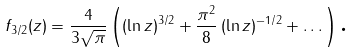<formula> <loc_0><loc_0><loc_500><loc_500>f _ { 3 / 2 } ( z ) = \frac { 4 } { 3 \sqrt { \pi } } \left ( \left ( \ln z \right ) ^ { 3 / 2 } + \frac { \pi ^ { 2 } } { 8 } \left ( \ln z \right ) ^ { - 1 / 2 } + \dots \right ) \text {.}</formula> 